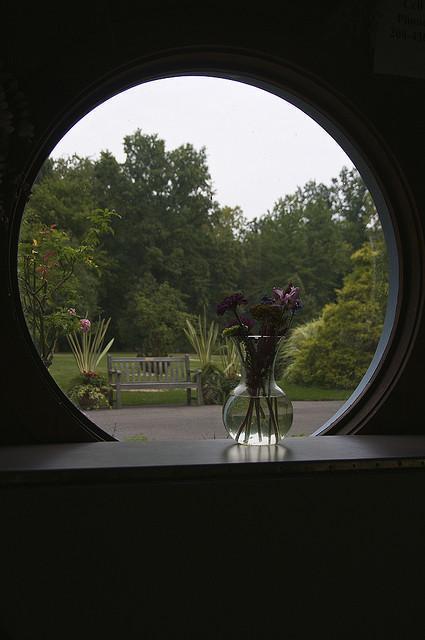How many potted plants are in the picture?
Give a very brief answer. 2. 